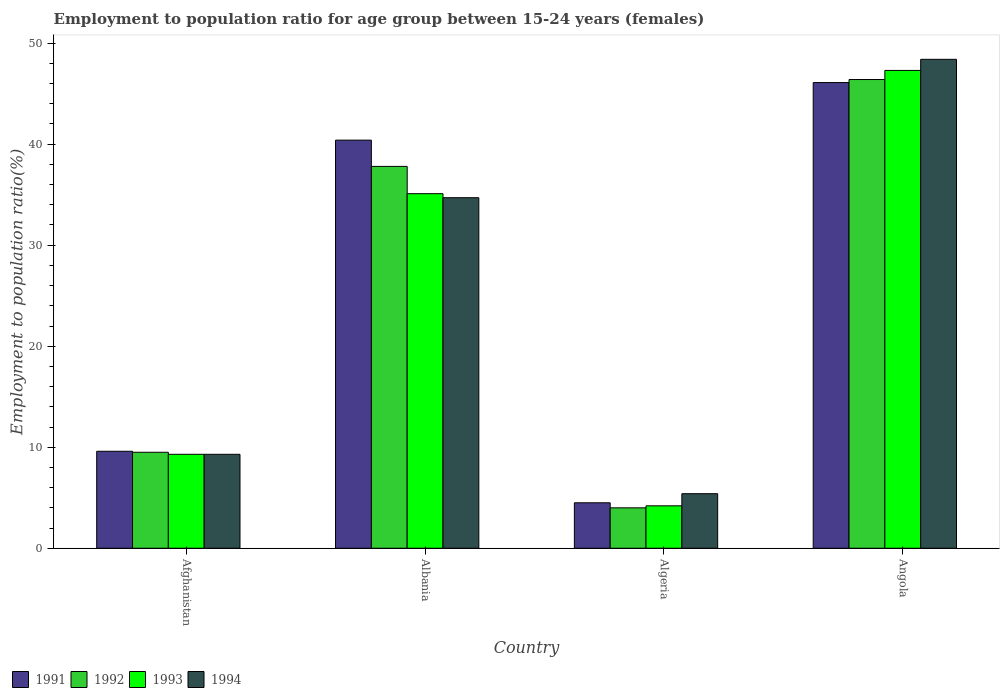How many groups of bars are there?
Offer a terse response. 4. Are the number of bars on each tick of the X-axis equal?
Your response must be concise. Yes. How many bars are there on the 3rd tick from the right?
Offer a terse response. 4. What is the label of the 4th group of bars from the left?
Your answer should be compact. Angola. In how many cases, is the number of bars for a given country not equal to the number of legend labels?
Give a very brief answer. 0. What is the employment to population ratio in 1991 in Afghanistan?
Your response must be concise. 9.6. Across all countries, what is the maximum employment to population ratio in 1993?
Give a very brief answer. 47.3. Across all countries, what is the minimum employment to population ratio in 1991?
Offer a terse response. 4.5. In which country was the employment to population ratio in 1993 maximum?
Give a very brief answer. Angola. In which country was the employment to population ratio in 1994 minimum?
Offer a terse response. Algeria. What is the total employment to population ratio in 1992 in the graph?
Give a very brief answer. 97.7. What is the difference between the employment to population ratio in 1994 in Afghanistan and that in Angola?
Make the answer very short. -39.1. What is the difference between the employment to population ratio in 1991 in Afghanistan and the employment to population ratio in 1993 in Angola?
Ensure brevity in your answer.  -37.7. What is the average employment to population ratio in 1992 per country?
Your answer should be compact. 24.43. What is the difference between the employment to population ratio of/in 1991 and employment to population ratio of/in 1992 in Angola?
Ensure brevity in your answer.  -0.3. In how many countries, is the employment to population ratio in 1994 greater than 4 %?
Give a very brief answer. 4. What is the ratio of the employment to population ratio in 1992 in Afghanistan to that in Albania?
Your response must be concise. 0.25. Is the difference between the employment to population ratio in 1991 in Albania and Angola greater than the difference between the employment to population ratio in 1992 in Albania and Angola?
Provide a succinct answer. Yes. What is the difference between the highest and the second highest employment to population ratio in 1993?
Make the answer very short. -25.8. What is the difference between the highest and the lowest employment to population ratio in 1993?
Your answer should be compact. 43.1. In how many countries, is the employment to population ratio in 1991 greater than the average employment to population ratio in 1991 taken over all countries?
Provide a short and direct response. 2. What does the 3rd bar from the right in Albania represents?
Ensure brevity in your answer.  1992. Are all the bars in the graph horizontal?
Ensure brevity in your answer.  No. Are the values on the major ticks of Y-axis written in scientific E-notation?
Ensure brevity in your answer.  No. Does the graph contain any zero values?
Ensure brevity in your answer.  No. Does the graph contain grids?
Ensure brevity in your answer.  No. Where does the legend appear in the graph?
Offer a terse response. Bottom left. How many legend labels are there?
Your response must be concise. 4. What is the title of the graph?
Your answer should be compact. Employment to population ratio for age group between 15-24 years (females). Does "2010" appear as one of the legend labels in the graph?
Make the answer very short. No. What is the Employment to population ratio(%) in 1991 in Afghanistan?
Provide a succinct answer. 9.6. What is the Employment to population ratio(%) in 1993 in Afghanistan?
Provide a succinct answer. 9.3. What is the Employment to population ratio(%) in 1994 in Afghanistan?
Provide a succinct answer. 9.3. What is the Employment to population ratio(%) in 1991 in Albania?
Offer a very short reply. 40.4. What is the Employment to population ratio(%) in 1992 in Albania?
Your answer should be compact. 37.8. What is the Employment to population ratio(%) of 1993 in Albania?
Provide a short and direct response. 35.1. What is the Employment to population ratio(%) in 1994 in Albania?
Offer a very short reply. 34.7. What is the Employment to population ratio(%) of 1992 in Algeria?
Your answer should be very brief. 4. What is the Employment to population ratio(%) in 1993 in Algeria?
Offer a very short reply. 4.2. What is the Employment to population ratio(%) of 1994 in Algeria?
Keep it short and to the point. 5.4. What is the Employment to population ratio(%) of 1991 in Angola?
Your answer should be compact. 46.1. What is the Employment to population ratio(%) of 1992 in Angola?
Your answer should be very brief. 46.4. What is the Employment to population ratio(%) of 1993 in Angola?
Ensure brevity in your answer.  47.3. What is the Employment to population ratio(%) in 1994 in Angola?
Keep it short and to the point. 48.4. Across all countries, what is the maximum Employment to population ratio(%) in 1991?
Offer a very short reply. 46.1. Across all countries, what is the maximum Employment to population ratio(%) in 1992?
Keep it short and to the point. 46.4. Across all countries, what is the maximum Employment to population ratio(%) of 1993?
Provide a short and direct response. 47.3. Across all countries, what is the maximum Employment to population ratio(%) in 1994?
Offer a very short reply. 48.4. Across all countries, what is the minimum Employment to population ratio(%) of 1991?
Your answer should be compact. 4.5. Across all countries, what is the minimum Employment to population ratio(%) of 1992?
Offer a very short reply. 4. Across all countries, what is the minimum Employment to population ratio(%) of 1993?
Offer a terse response. 4.2. Across all countries, what is the minimum Employment to population ratio(%) of 1994?
Your answer should be compact. 5.4. What is the total Employment to population ratio(%) of 1991 in the graph?
Ensure brevity in your answer.  100.6. What is the total Employment to population ratio(%) of 1992 in the graph?
Ensure brevity in your answer.  97.7. What is the total Employment to population ratio(%) of 1993 in the graph?
Your response must be concise. 95.9. What is the total Employment to population ratio(%) of 1994 in the graph?
Your answer should be very brief. 97.8. What is the difference between the Employment to population ratio(%) of 1991 in Afghanistan and that in Albania?
Give a very brief answer. -30.8. What is the difference between the Employment to population ratio(%) of 1992 in Afghanistan and that in Albania?
Offer a very short reply. -28.3. What is the difference between the Employment to population ratio(%) of 1993 in Afghanistan and that in Albania?
Offer a terse response. -25.8. What is the difference between the Employment to population ratio(%) in 1994 in Afghanistan and that in Albania?
Make the answer very short. -25.4. What is the difference between the Employment to population ratio(%) in 1991 in Afghanistan and that in Algeria?
Offer a very short reply. 5.1. What is the difference between the Employment to population ratio(%) of 1992 in Afghanistan and that in Algeria?
Provide a succinct answer. 5.5. What is the difference between the Employment to population ratio(%) of 1993 in Afghanistan and that in Algeria?
Your answer should be compact. 5.1. What is the difference between the Employment to population ratio(%) in 1994 in Afghanistan and that in Algeria?
Offer a very short reply. 3.9. What is the difference between the Employment to population ratio(%) in 1991 in Afghanistan and that in Angola?
Your answer should be very brief. -36.5. What is the difference between the Employment to population ratio(%) in 1992 in Afghanistan and that in Angola?
Offer a terse response. -36.9. What is the difference between the Employment to population ratio(%) of 1993 in Afghanistan and that in Angola?
Give a very brief answer. -38. What is the difference between the Employment to population ratio(%) of 1994 in Afghanistan and that in Angola?
Make the answer very short. -39.1. What is the difference between the Employment to population ratio(%) in 1991 in Albania and that in Algeria?
Your answer should be very brief. 35.9. What is the difference between the Employment to population ratio(%) of 1992 in Albania and that in Algeria?
Your answer should be compact. 33.8. What is the difference between the Employment to population ratio(%) in 1993 in Albania and that in Algeria?
Your response must be concise. 30.9. What is the difference between the Employment to population ratio(%) in 1994 in Albania and that in Algeria?
Offer a terse response. 29.3. What is the difference between the Employment to population ratio(%) in 1991 in Albania and that in Angola?
Ensure brevity in your answer.  -5.7. What is the difference between the Employment to population ratio(%) in 1992 in Albania and that in Angola?
Offer a terse response. -8.6. What is the difference between the Employment to population ratio(%) of 1993 in Albania and that in Angola?
Offer a terse response. -12.2. What is the difference between the Employment to population ratio(%) of 1994 in Albania and that in Angola?
Provide a short and direct response. -13.7. What is the difference between the Employment to population ratio(%) in 1991 in Algeria and that in Angola?
Your answer should be very brief. -41.6. What is the difference between the Employment to population ratio(%) in 1992 in Algeria and that in Angola?
Ensure brevity in your answer.  -42.4. What is the difference between the Employment to population ratio(%) of 1993 in Algeria and that in Angola?
Your answer should be very brief. -43.1. What is the difference between the Employment to population ratio(%) in 1994 in Algeria and that in Angola?
Your answer should be compact. -43. What is the difference between the Employment to population ratio(%) of 1991 in Afghanistan and the Employment to population ratio(%) of 1992 in Albania?
Make the answer very short. -28.2. What is the difference between the Employment to population ratio(%) in 1991 in Afghanistan and the Employment to population ratio(%) in 1993 in Albania?
Offer a terse response. -25.5. What is the difference between the Employment to population ratio(%) in 1991 in Afghanistan and the Employment to population ratio(%) in 1994 in Albania?
Provide a short and direct response. -25.1. What is the difference between the Employment to population ratio(%) in 1992 in Afghanistan and the Employment to population ratio(%) in 1993 in Albania?
Give a very brief answer. -25.6. What is the difference between the Employment to population ratio(%) of 1992 in Afghanistan and the Employment to population ratio(%) of 1994 in Albania?
Your answer should be very brief. -25.2. What is the difference between the Employment to population ratio(%) of 1993 in Afghanistan and the Employment to population ratio(%) of 1994 in Albania?
Provide a succinct answer. -25.4. What is the difference between the Employment to population ratio(%) in 1991 in Afghanistan and the Employment to population ratio(%) in 1993 in Algeria?
Keep it short and to the point. 5.4. What is the difference between the Employment to population ratio(%) in 1991 in Afghanistan and the Employment to population ratio(%) in 1994 in Algeria?
Ensure brevity in your answer.  4.2. What is the difference between the Employment to population ratio(%) of 1992 in Afghanistan and the Employment to population ratio(%) of 1994 in Algeria?
Your answer should be very brief. 4.1. What is the difference between the Employment to population ratio(%) of 1993 in Afghanistan and the Employment to population ratio(%) of 1994 in Algeria?
Your answer should be compact. 3.9. What is the difference between the Employment to population ratio(%) in 1991 in Afghanistan and the Employment to population ratio(%) in 1992 in Angola?
Make the answer very short. -36.8. What is the difference between the Employment to population ratio(%) in 1991 in Afghanistan and the Employment to population ratio(%) in 1993 in Angola?
Provide a short and direct response. -37.7. What is the difference between the Employment to population ratio(%) of 1991 in Afghanistan and the Employment to population ratio(%) of 1994 in Angola?
Provide a succinct answer. -38.8. What is the difference between the Employment to population ratio(%) of 1992 in Afghanistan and the Employment to population ratio(%) of 1993 in Angola?
Your answer should be very brief. -37.8. What is the difference between the Employment to population ratio(%) of 1992 in Afghanistan and the Employment to population ratio(%) of 1994 in Angola?
Make the answer very short. -38.9. What is the difference between the Employment to population ratio(%) in 1993 in Afghanistan and the Employment to population ratio(%) in 1994 in Angola?
Offer a very short reply. -39.1. What is the difference between the Employment to population ratio(%) of 1991 in Albania and the Employment to population ratio(%) of 1992 in Algeria?
Offer a very short reply. 36.4. What is the difference between the Employment to population ratio(%) of 1991 in Albania and the Employment to population ratio(%) of 1993 in Algeria?
Your answer should be very brief. 36.2. What is the difference between the Employment to population ratio(%) of 1991 in Albania and the Employment to population ratio(%) of 1994 in Algeria?
Give a very brief answer. 35. What is the difference between the Employment to population ratio(%) in 1992 in Albania and the Employment to population ratio(%) in 1993 in Algeria?
Give a very brief answer. 33.6. What is the difference between the Employment to population ratio(%) of 1992 in Albania and the Employment to population ratio(%) of 1994 in Algeria?
Your answer should be compact. 32.4. What is the difference between the Employment to population ratio(%) in 1993 in Albania and the Employment to population ratio(%) in 1994 in Algeria?
Give a very brief answer. 29.7. What is the difference between the Employment to population ratio(%) of 1992 in Albania and the Employment to population ratio(%) of 1993 in Angola?
Make the answer very short. -9.5. What is the difference between the Employment to population ratio(%) in 1993 in Albania and the Employment to population ratio(%) in 1994 in Angola?
Provide a succinct answer. -13.3. What is the difference between the Employment to population ratio(%) of 1991 in Algeria and the Employment to population ratio(%) of 1992 in Angola?
Provide a short and direct response. -41.9. What is the difference between the Employment to population ratio(%) of 1991 in Algeria and the Employment to population ratio(%) of 1993 in Angola?
Give a very brief answer. -42.8. What is the difference between the Employment to population ratio(%) in 1991 in Algeria and the Employment to population ratio(%) in 1994 in Angola?
Ensure brevity in your answer.  -43.9. What is the difference between the Employment to population ratio(%) in 1992 in Algeria and the Employment to population ratio(%) in 1993 in Angola?
Provide a short and direct response. -43.3. What is the difference between the Employment to population ratio(%) in 1992 in Algeria and the Employment to population ratio(%) in 1994 in Angola?
Offer a very short reply. -44.4. What is the difference between the Employment to population ratio(%) in 1993 in Algeria and the Employment to population ratio(%) in 1994 in Angola?
Your answer should be very brief. -44.2. What is the average Employment to population ratio(%) in 1991 per country?
Make the answer very short. 25.15. What is the average Employment to population ratio(%) of 1992 per country?
Offer a terse response. 24.43. What is the average Employment to population ratio(%) in 1993 per country?
Make the answer very short. 23.98. What is the average Employment to population ratio(%) in 1994 per country?
Provide a short and direct response. 24.45. What is the difference between the Employment to population ratio(%) in 1991 and Employment to population ratio(%) in 1993 in Afghanistan?
Your answer should be compact. 0.3. What is the difference between the Employment to population ratio(%) of 1991 and Employment to population ratio(%) of 1994 in Afghanistan?
Ensure brevity in your answer.  0.3. What is the difference between the Employment to population ratio(%) in 1992 and Employment to population ratio(%) in 1993 in Afghanistan?
Ensure brevity in your answer.  0.2. What is the difference between the Employment to population ratio(%) in 1993 and Employment to population ratio(%) in 1994 in Afghanistan?
Offer a terse response. 0. What is the difference between the Employment to population ratio(%) of 1991 and Employment to population ratio(%) of 1994 in Albania?
Give a very brief answer. 5.7. What is the difference between the Employment to population ratio(%) in 1992 and Employment to population ratio(%) in 1994 in Albania?
Your answer should be compact. 3.1. What is the difference between the Employment to population ratio(%) in 1992 and Employment to population ratio(%) in 1993 in Algeria?
Your answer should be very brief. -0.2. What is the difference between the Employment to population ratio(%) of 1991 and Employment to population ratio(%) of 1993 in Angola?
Your answer should be very brief. -1.2. What is the ratio of the Employment to population ratio(%) in 1991 in Afghanistan to that in Albania?
Give a very brief answer. 0.24. What is the ratio of the Employment to population ratio(%) of 1992 in Afghanistan to that in Albania?
Give a very brief answer. 0.25. What is the ratio of the Employment to population ratio(%) of 1993 in Afghanistan to that in Albania?
Provide a succinct answer. 0.27. What is the ratio of the Employment to population ratio(%) of 1994 in Afghanistan to that in Albania?
Offer a very short reply. 0.27. What is the ratio of the Employment to population ratio(%) of 1991 in Afghanistan to that in Algeria?
Offer a terse response. 2.13. What is the ratio of the Employment to population ratio(%) of 1992 in Afghanistan to that in Algeria?
Give a very brief answer. 2.38. What is the ratio of the Employment to population ratio(%) in 1993 in Afghanistan to that in Algeria?
Your answer should be compact. 2.21. What is the ratio of the Employment to population ratio(%) in 1994 in Afghanistan to that in Algeria?
Your answer should be compact. 1.72. What is the ratio of the Employment to population ratio(%) of 1991 in Afghanistan to that in Angola?
Your answer should be compact. 0.21. What is the ratio of the Employment to population ratio(%) in 1992 in Afghanistan to that in Angola?
Provide a short and direct response. 0.2. What is the ratio of the Employment to population ratio(%) in 1993 in Afghanistan to that in Angola?
Your answer should be compact. 0.2. What is the ratio of the Employment to population ratio(%) of 1994 in Afghanistan to that in Angola?
Offer a terse response. 0.19. What is the ratio of the Employment to population ratio(%) in 1991 in Albania to that in Algeria?
Your answer should be compact. 8.98. What is the ratio of the Employment to population ratio(%) of 1992 in Albania to that in Algeria?
Make the answer very short. 9.45. What is the ratio of the Employment to population ratio(%) in 1993 in Albania to that in Algeria?
Keep it short and to the point. 8.36. What is the ratio of the Employment to population ratio(%) in 1994 in Albania to that in Algeria?
Give a very brief answer. 6.43. What is the ratio of the Employment to population ratio(%) of 1991 in Albania to that in Angola?
Offer a very short reply. 0.88. What is the ratio of the Employment to population ratio(%) of 1992 in Albania to that in Angola?
Ensure brevity in your answer.  0.81. What is the ratio of the Employment to population ratio(%) in 1993 in Albania to that in Angola?
Provide a short and direct response. 0.74. What is the ratio of the Employment to population ratio(%) in 1994 in Albania to that in Angola?
Your answer should be compact. 0.72. What is the ratio of the Employment to population ratio(%) in 1991 in Algeria to that in Angola?
Offer a very short reply. 0.1. What is the ratio of the Employment to population ratio(%) in 1992 in Algeria to that in Angola?
Offer a very short reply. 0.09. What is the ratio of the Employment to population ratio(%) of 1993 in Algeria to that in Angola?
Provide a succinct answer. 0.09. What is the ratio of the Employment to population ratio(%) in 1994 in Algeria to that in Angola?
Provide a succinct answer. 0.11. What is the difference between the highest and the second highest Employment to population ratio(%) in 1991?
Provide a succinct answer. 5.7. What is the difference between the highest and the second highest Employment to population ratio(%) in 1992?
Provide a succinct answer. 8.6. What is the difference between the highest and the second highest Employment to population ratio(%) of 1993?
Provide a short and direct response. 12.2. What is the difference between the highest and the lowest Employment to population ratio(%) of 1991?
Provide a short and direct response. 41.6. What is the difference between the highest and the lowest Employment to population ratio(%) in 1992?
Your response must be concise. 42.4. What is the difference between the highest and the lowest Employment to population ratio(%) in 1993?
Provide a succinct answer. 43.1. What is the difference between the highest and the lowest Employment to population ratio(%) of 1994?
Your answer should be very brief. 43. 